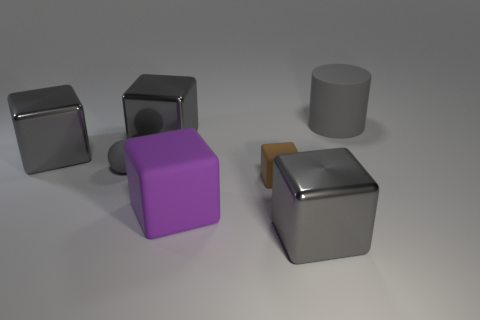Subtract all gray blocks. How many were subtracted if there are1gray blocks left? 2 Subtract all matte blocks. How many blocks are left? 3 Subtract all purple cubes. How many cubes are left? 4 Add 1 purple objects. How many objects exist? 8 Subtract 1 cylinders. How many cylinders are left? 0 Add 7 big purple things. How many big purple things exist? 8 Subtract 1 purple cubes. How many objects are left? 6 Subtract all balls. How many objects are left? 6 Subtract all brown cylinders. Subtract all purple blocks. How many cylinders are left? 1 Subtract all blue spheres. How many gray blocks are left? 3 